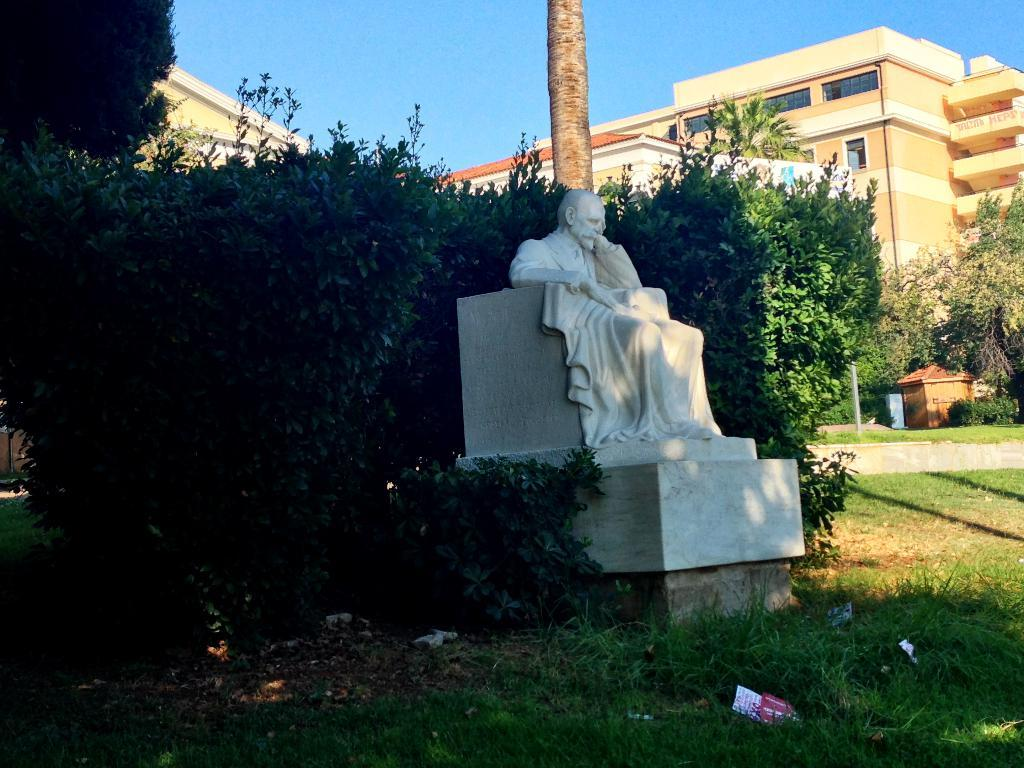What is the statue in the image depicting? The statue is a white color statue of a person sitting. What type of terrain is visible in the image? There is grass visible in the image. What can be seen in the background of the image? There are trees, a wooden house, and other buildings in the background of the image. What color is the sky in the image? The sky is blue in the background of the image. What is on the list that the statue is holding in the image? There is no list present in the image; the statue is simply sitting. 